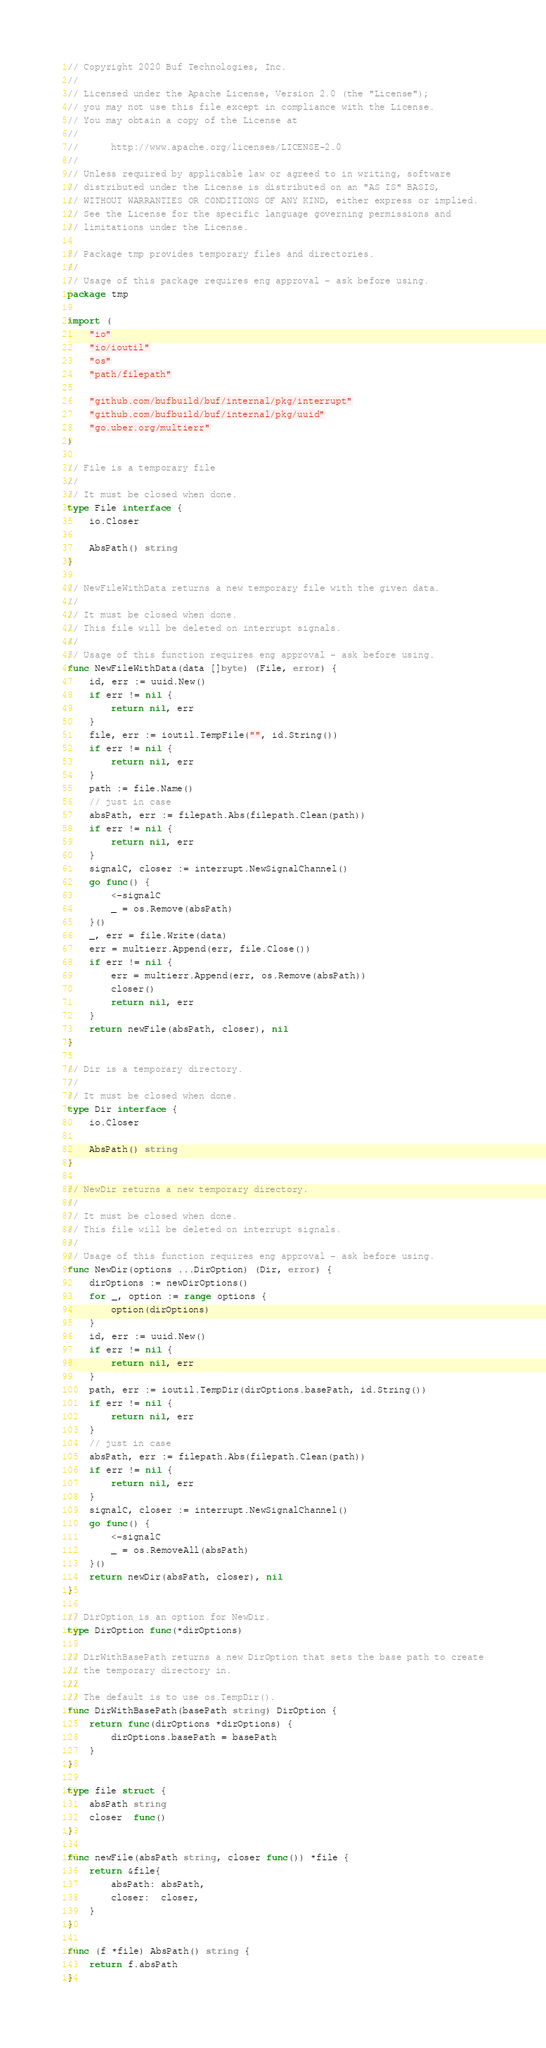<code> <loc_0><loc_0><loc_500><loc_500><_Go_>// Copyright 2020 Buf Technologies, Inc.
//
// Licensed under the Apache License, Version 2.0 (the "License");
// you may not use this file except in compliance with the License.
// You may obtain a copy of the License at
//
//      http://www.apache.org/licenses/LICENSE-2.0
//
// Unless required by applicable law or agreed to in writing, software
// distributed under the License is distributed on an "AS IS" BASIS,
// WITHOUT WARRANTIES OR CONDITIONS OF ANY KIND, either express or implied.
// See the License for the specific language governing permissions and
// limitations under the License.

// Package tmp provides temporary files and directories.
//
// Usage of this package requires eng approval - ask before using.
package tmp

import (
	"io"
	"io/ioutil"
	"os"
	"path/filepath"

	"github.com/bufbuild/buf/internal/pkg/interrupt"
	"github.com/bufbuild/buf/internal/pkg/uuid"
	"go.uber.org/multierr"
)

// File is a temporary file
//
// It must be closed when done.
type File interface {
	io.Closer

	AbsPath() string
}

// NewFileWithData returns a new temporary file with the given data.
//
// It must be closed when done.
// This file will be deleted on interrupt signals.
//
// Usage of this function requires eng approval - ask before using.
func NewFileWithData(data []byte) (File, error) {
	id, err := uuid.New()
	if err != nil {
		return nil, err
	}
	file, err := ioutil.TempFile("", id.String())
	if err != nil {
		return nil, err
	}
	path := file.Name()
	// just in case
	absPath, err := filepath.Abs(filepath.Clean(path))
	if err != nil {
		return nil, err
	}
	signalC, closer := interrupt.NewSignalChannel()
	go func() {
		<-signalC
		_ = os.Remove(absPath)
	}()
	_, err = file.Write(data)
	err = multierr.Append(err, file.Close())
	if err != nil {
		err = multierr.Append(err, os.Remove(absPath))
		closer()
		return nil, err
	}
	return newFile(absPath, closer), nil
}

// Dir is a temporary directory.
//
// It must be closed when done.
type Dir interface {
	io.Closer

	AbsPath() string
}

// NewDir returns a new temporary directory.
//
// It must be closed when done.
// This file will be deleted on interrupt signals.
//
// Usage of this function requires eng approval - ask before using.
func NewDir(options ...DirOption) (Dir, error) {
	dirOptions := newDirOptions()
	for _, option := range options {
		option(dirOptions)
	}
	id, err := uuid.New()
	if err != nil {
		return nil, err
	}
	path, err := ioutil.TempDir(dirOptions.basePath, id.String())
	if err != nil {
		return nil, err
	}
	// just in case
	absPath, err := filepath.Abs(filepath.Clean(path))
	if err != nil {
		return nil, err
	}
	signalC, closer := interrupt.NewSignalChannel()
	go func() {
		<-signalC
		_ = os.RemoveAll(absPath)
	}()
	return newDir(absPath, closer), nil
}

// DirOption is an option for NewDir.
type DirOption func(*dirOptions)

// DirWithBasePath returns a new DirOption that sets the base path to create
// the temporary directory in.
//
// The default is to use os.TempDir().
func DirWithBasePath(basePath string) DirOption {
	return func(dirOptions *dirOptions) {
		dirOptions.basePath = basePath
	}
}

type file struct {
	absPath string
	closer  func()
}

func newFile(absPath string, closer func()) *file {
	return &file{
		absPath: absPath,
		closer:  closer,
	}
}

func (f *file) AbsPath() string {
	return f.absPath
}
</code> 